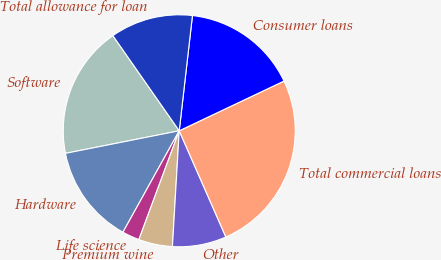Convert chart. <chart><loc_0><loc_0><loc_500><loc_500><pie_chart><fcel>Software<fcel>Hardware<fcel>Life science<fcel>Premium wine<fcel>Other<fcel>Total commercial loans<fcel>Consumer loans<fcel>Total allowance for loan<nl><fcel>18.43%<fcel>13.82%<fcel>2.41%<fcel>4.72%<fcel>7.52%<fcel>25.47%<fcel>16.13%<fcel>11.51%<nl></chart> 